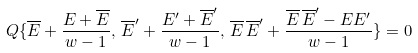Convert formula to latex. <formula><loc_0><loc_0><loc_500><loc_500>Q \{ { \overline { E } } + \frac { E + \overline { E } } { w - 1 } , \, \overline { E } ^ { \prime } + \frac { E ^ { \prime } + \overline { E } ^ { \prime } } { w - 1 } , \, { \overline { E } } \, { \overline { E } ^ { \prime } } + \frac { { \overline { E } } \, { \overline { E } ^ { \prime } } - E E ^ { \prime } } { w - 1 } \} = 0</formula> 